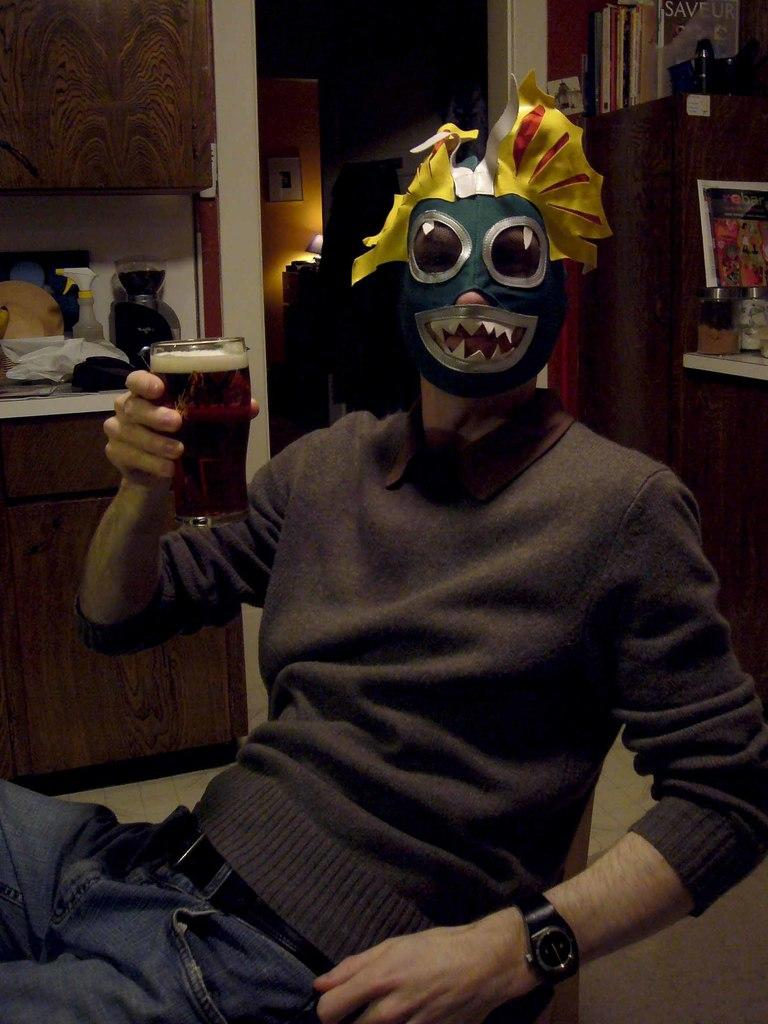What type of structure can be seen in the image? There is a wall in the image. Is there any entrance visible in the image? Yes, there is a door in the image. What is the man in the image doing? The man is sitting on a chair in the image. What furniture is present in the image? There is a table in the image. What object is on the table in the image? There is a bottle on the table in the image. Can you see a tree blowing in the wind in the image? There is no tree or wind visible in the image. Is there an agreement being signed in the image? There is no indication of an agreement or signing in the image. 